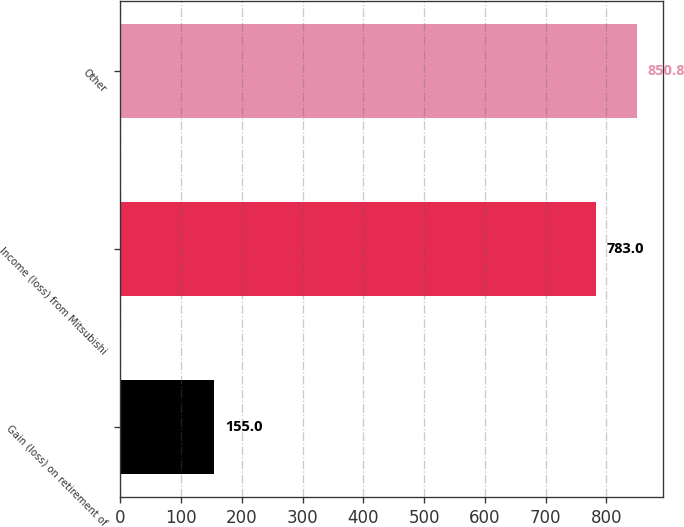<chart> <loc_0><loc_0><loc_500><loc_500><bar_chart><fcel>Gain (loss) on retirement of<fcel>Income (loss) from Mitsubishi<fcel>Other<nl><fcel>155<fcel>783<fcel>850.8<nl></chart> 